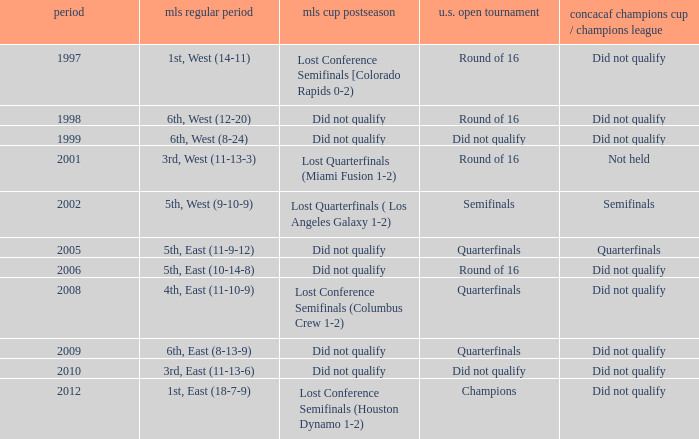When was the first season? 1997.0. 